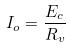<formula> <loc_0><loc_0><loc_500><loc_500>I _ { o } = \frac { E _ { c } } { R _ { v } }</formula> 